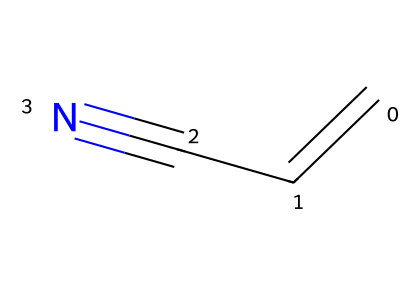What is the molecular formula of acrylonitrile? The SMILES representation shows one carbon double bonded to another carbon, which is then triple bonded to a nitrogen atom. By counting the atoms, we find 3 carbon atoms, 3 hydrogen atoms, and 1 nitrogen atom. Therefore, the molecular formula is C3H3N.
Answer: C3H3N How many double bonds are present in acrylonitrile? In the SMILES representation, there is one double bond between the first two carbon atoms (C=C). Counting gives us one double bond in the structure of acrylonitrile.
Answer: 1 What functional group is indicated by the presence of the nitrogen atom? The presence of the nitrogen atom in a nitrile structure indicates that the compound belongs to the functional group of nitriles. This is defined by the presence of a carbon atom triple bonded to a nitrogen atom.
Answer: nitrile Does acrylonitrile contain any rings in its structure? The SMILES representation shows a linear structure with no cyclic connections or rings included in the depiction. Thus, acrylonitrile does not contain any rings.
Answer: No What is the main use of acrylonitrile in industry? Acrylonitrile is primarily used as a precursor in the production of synthetic rubber, which is utilized in various applications such as tires and other rubber products. This usage highlights its importance in industrial processes.
Answer: synthetic rubber production How many total atoms are in the acrylonitrile molecule? The analysis of the molecular formula (C3H3N) reveals a total of 7 atoms: 3 carbon atoms, 3 hydrogen atoms, and 1 nitrogen atom. Adding these gives us 7 total atoms in the molecule.
Answer: 7 